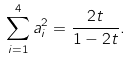Convert formula to latex. <formula><loc_0><loc_0><loc_500><loc_500>\sum _ { i = 1 } ^ { 4 } a _ { i } ^ { 2 } = \frac { 2 t } { 1 - 2 t } .</formula> 